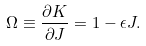Convert formula to latex. <formula><loc_0><loc_0><loc_500><loc_500>\Omega \equiv \frac { \partial K } { \partial J } = 1 - \epsilon J .</formula> 